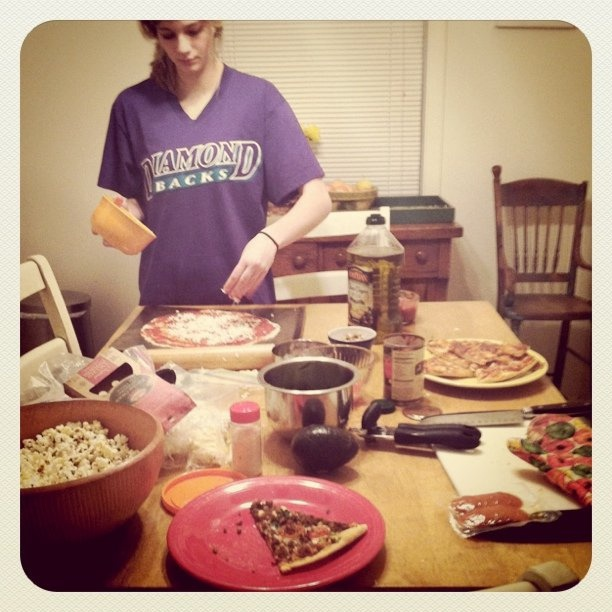Describe the objects in this image and their specific colors. I can see people in ivory, purple, gray, and tan tones, dining table in ivory, tan, black, and brown tones, bowl in ivory, maroon, brown, black, and tan tones, chair in ivory, maroon, gray, tan, and brown tones, and bowl in ivory, maroon, brown, and tan tones in this image. 